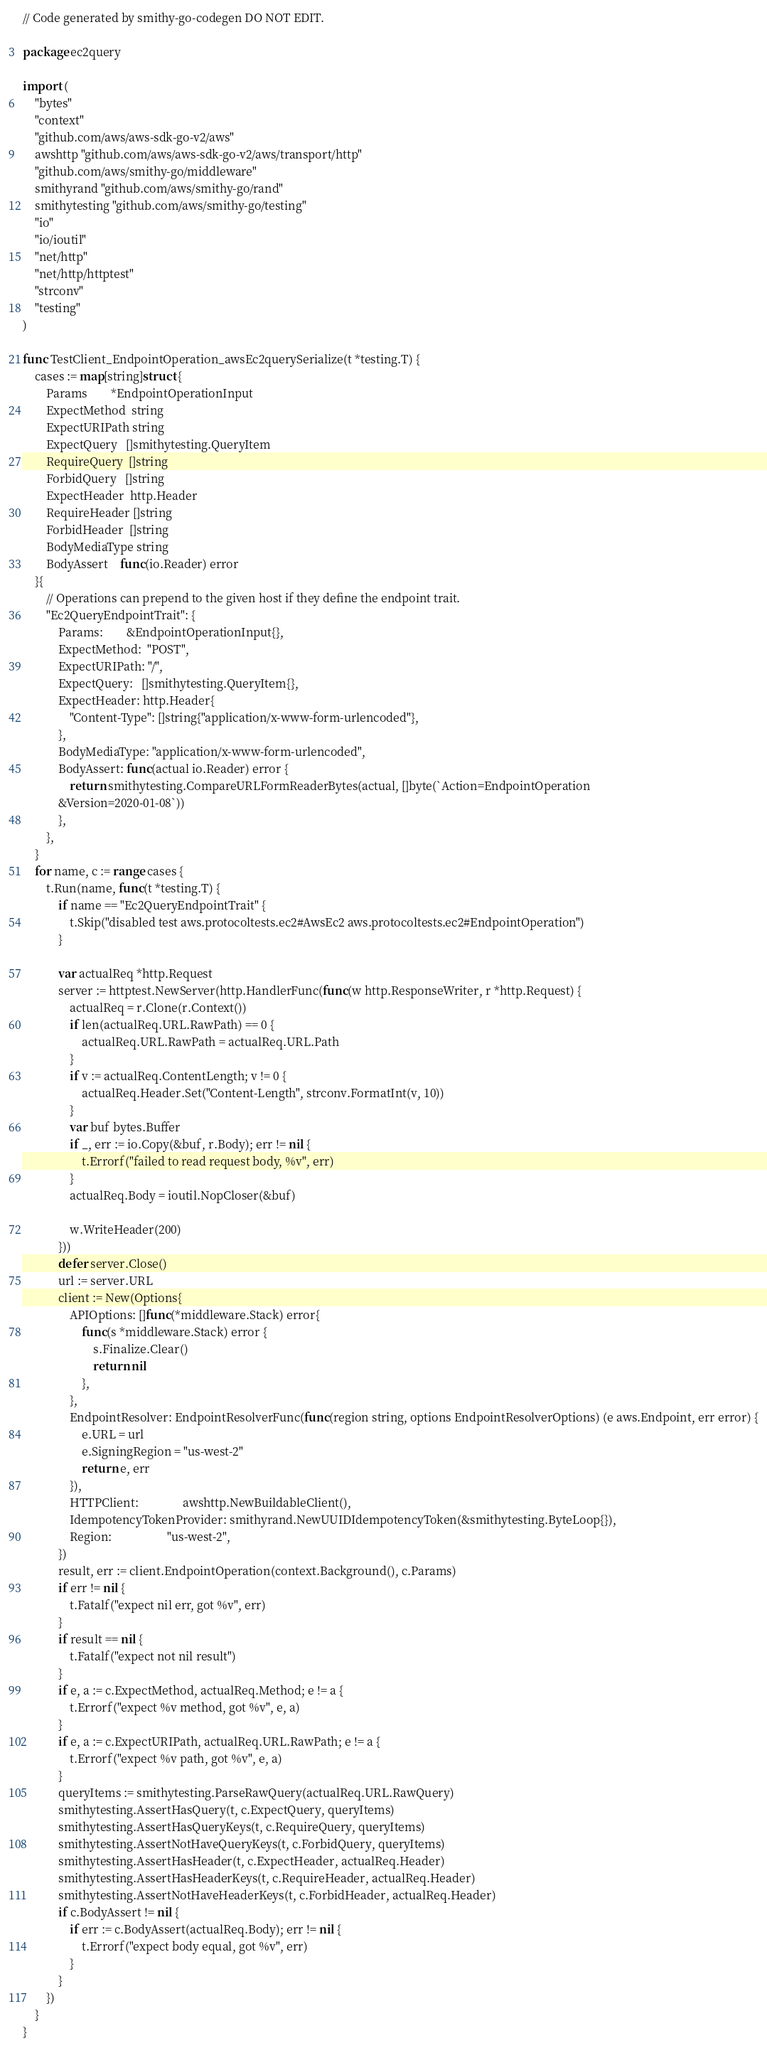<code> <loc_0><loc_0><loc_500><loc_500><_Go_>// Code generated by smithy-go-codegen DO NOT EDIT.

package ec2query

import (
	"bytes"
	"context"
	"github.com/aws/aws-sdk-go-v2/aws"
	awshttp "github.com/aws/aws-sdk-go-v2/aws/transport/http"
	"github.com/aws/smithy-go/middleware"
	smithyrand "github.com/aws/smithy-go/rand"
	smithytesting "github.com/aws/smithy-go/testing"
	"io"
	"io/ioutil"
	"net/http"
	"net/http/httptest"
	"strconv"
	"testing"
)

func TestClient_EndpointOperation_awsEc2querySerialize(t *testing.T) {
	cases := map[string]struct {
		Params        *EndpointOperationInput
		ExpectMethod  string
		ExpectURIPath string
		ExpectQuery   []smithytesting.QueryItem
		RequireQuery  []string
		ForbidQuery   []string
		ExpectHeader  http.Header
		RequireHeader []string
		ForbidHeader  []string
		BodyMediaType string
		BodyAssert    func(io.Reader) error
	}{
		// Operations can prepend to the given host if they define the endpoint trait.
		"Ec2QueryEndpointTrait": {
			Params:        &EndpointOperationInput{},
			ExpectMethod:  "POST",
			ExpectURIPath: "/",
			ExpectQuery:   []smithytesting.QueryItem{},
			ExpectHeader: http.Header{
				"Content-Type": []string{"application/x-www-form-urlencoded"},
			},
			BodyMediaType: "application/x-www-form-urlencoded",
			BodyAssert: func(actual io.Reader) error {
				return smithytesting.CompareURLFormReaderBytes(actual, []byte(`Action=EndpointOperation
			&Version=2020-01-08`))
			},
		},
	}
	for name, c := range cases {
		t.Run(name, func(t *testing.T) {
			if name == "Ec2QueryEndpointTrait" {
				t.Skip("disabled test aws.protocoltests.ec2#AwsEc2 aws.protocoltests.ec2#EndpointOperation")
			}

			var actualReq *http.Request
			server := httptest.NewServer(http.HandlerFunc(func(w http.ResponseWriter, r *http.Request) {
				actualReq = r.Clone(r.Context())
				if len(actualReq.URL.RawPath) == 0 {
					actualReq.URL.RawPath = actualReq.URL.Path
				}
				if v := actualReq.ContentLength; v != 0 {
					actualReq.Header.Set("Content-Length", strconv.FormatInt(v, 10))
				}
				var buf bytes.Buffer
				if _, err := io.Copy(&buf, r.Body); err != nil {
					t.Errorf("failed to read request body, %v", err)
				}
				actualReq.Body = ioutil.NopCloser(&buf)

				w.WriteHeader(200)
			}))
			defer server.Close()
			url := server.URL
			client := New(Options{
				APIOptions: []func(*middleware.Stack) error{
					func(s *middleware.Stack) error {
						s.Finalize.Clear()
						return nil
					},
				},
				EndpointResolver: EndpointResolverFunc(func(region string, options EndpointResolverOptions) (e aws.Endpoint, err error) {
					e.URL = url
					e.SigningRegion = "us-west-2"
					return e, err
				}),
				HTTPClient:               awshttp.NewBuildableClient(),
				IdempotencyTokenProvider: smithyrand.NewUUIDIdempotencyToken(&smithytesting.ByteLoop{}),
				Region:                   "us-west-2",
			})
			result, err := client.EndpointOperation(context.Background(), c.Params)
			if err != nil {
				t.Fatalf("expect nil err, got %v", err)
			}
			if result == nil {
				t.Fatalf("expect not nil result")
			}
			if e, a := c.ExpectMethod, actualReq.Method; e != a {
				t.Errorf("expect %v method, got %v", e, a)
			}
			if e, a := c.ExpectURIPath, actualReq.URL.RawPath; e != a {
				t.Errorf("expect %v path, got %v", e, a)
			}
			queryItems := smithytesting.ParseRawQuery(actualReq.URL.RawQuery)
			smithytesting.AssertHasQuery(t, c.ExpectQuery, queryItems)
			smithytesting.AssertHasQueryKeys(t, c.RequireQuery, queryItems)
			smithytesting.AssertNotHaveQueryKeys(t, c.ForbidQuery, queryItems)
			smithytesting.AssertHasHeader(t, c.ExpectHeader, actualReq.Header)
			smithytesting.AssertHasHeaderKeys(t, c.RequireHeader, actualReq.Header)
			smithytesting.AssertNotHaveHeaderKeys(t, c.ForbidHeader, actualReq.Header)
			if c.BodyAssert != nil {
				if err := c.BodyAssert(actualReq.Body); err != nil {
					t.Errorf("expect body equal, got %v", err)
				}
			}
		})
	}
}
</code> 